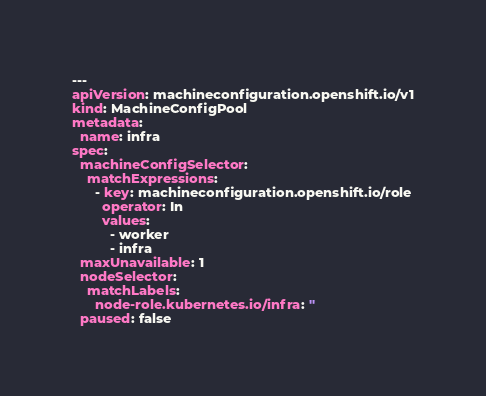<code> <loc_0><loc_0><loc_500><loc_500><_YAML_>---
apiVersion: machineconfiguration.openshift.io/v1
kind: MachineConfigPool
metadata:
  name: infra
spec:
  machineConfigSelector:
    matchExpressions:
      - key: machineconfiguration.openshift.io/role
        operator: In
        values:
          - worker
          - infra
  maxUnavailable: 1
  nodeSelector:
    matchLabels:
      node-role.kubernetes.io/infra: ''
  paused: false
</code> 